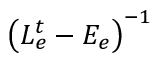Convert formula to latex. <formula><loc_0><loc_0><loc_500><loc_500>\left ( L _ { e } ^ { t } - E _ { e } \right ) ^ { - 1 }</formula> 